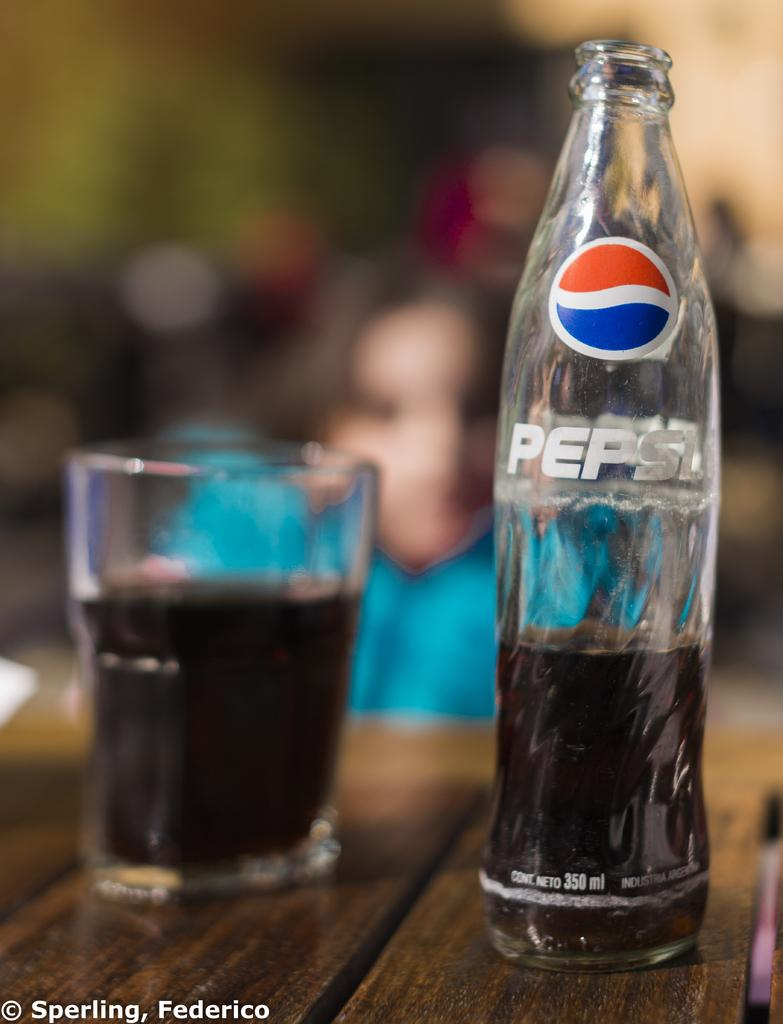Provide a one-sentence caption for the provided image. A glass bottle of Pepsi sits next to a glass of the drink. 